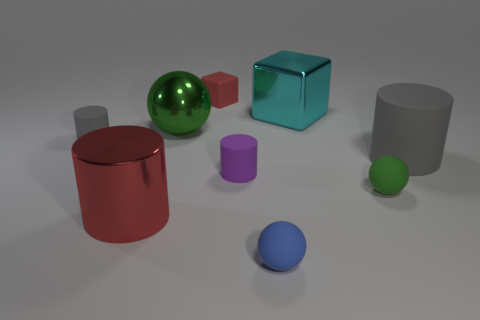There is a object that is the same color as the small block; what size is it?
Offer a terse response. Large. There is a sphere in front of the green rubber thing; is it the same size as the red thing that is in front of the big gray cylinder?
Ensure brevity in your answer.  No. There is a gray thing on the left side of the big shiny sphere; how big is it?
Provide a succinct answer. Small. There is a big object that is the same color as the tiny matte cube; what material is it?
Provide a succinct answer. Metal. What is the color of the other rubber cylinder that is the same size as the purple matte cylinder?
Your response must be concise. Gray. Do the green metallic thing and the cyan metal thing have the same size?
Make the answer very short. Yes. There is a rubber thing that is behind the large gray matte object and in front of the red rubber object; what is its size?
Provide a short and direct response. Small. What number of matte objects are small things or green things?
Provide a succinct answer. 5. Are there more green spheres behind the green rubber thing than large yellow spheres?
Make the answer very short. Yes. What is the material of the cylinder on the right side of the green rubber thing?
Offer a terse response. Rubber. 